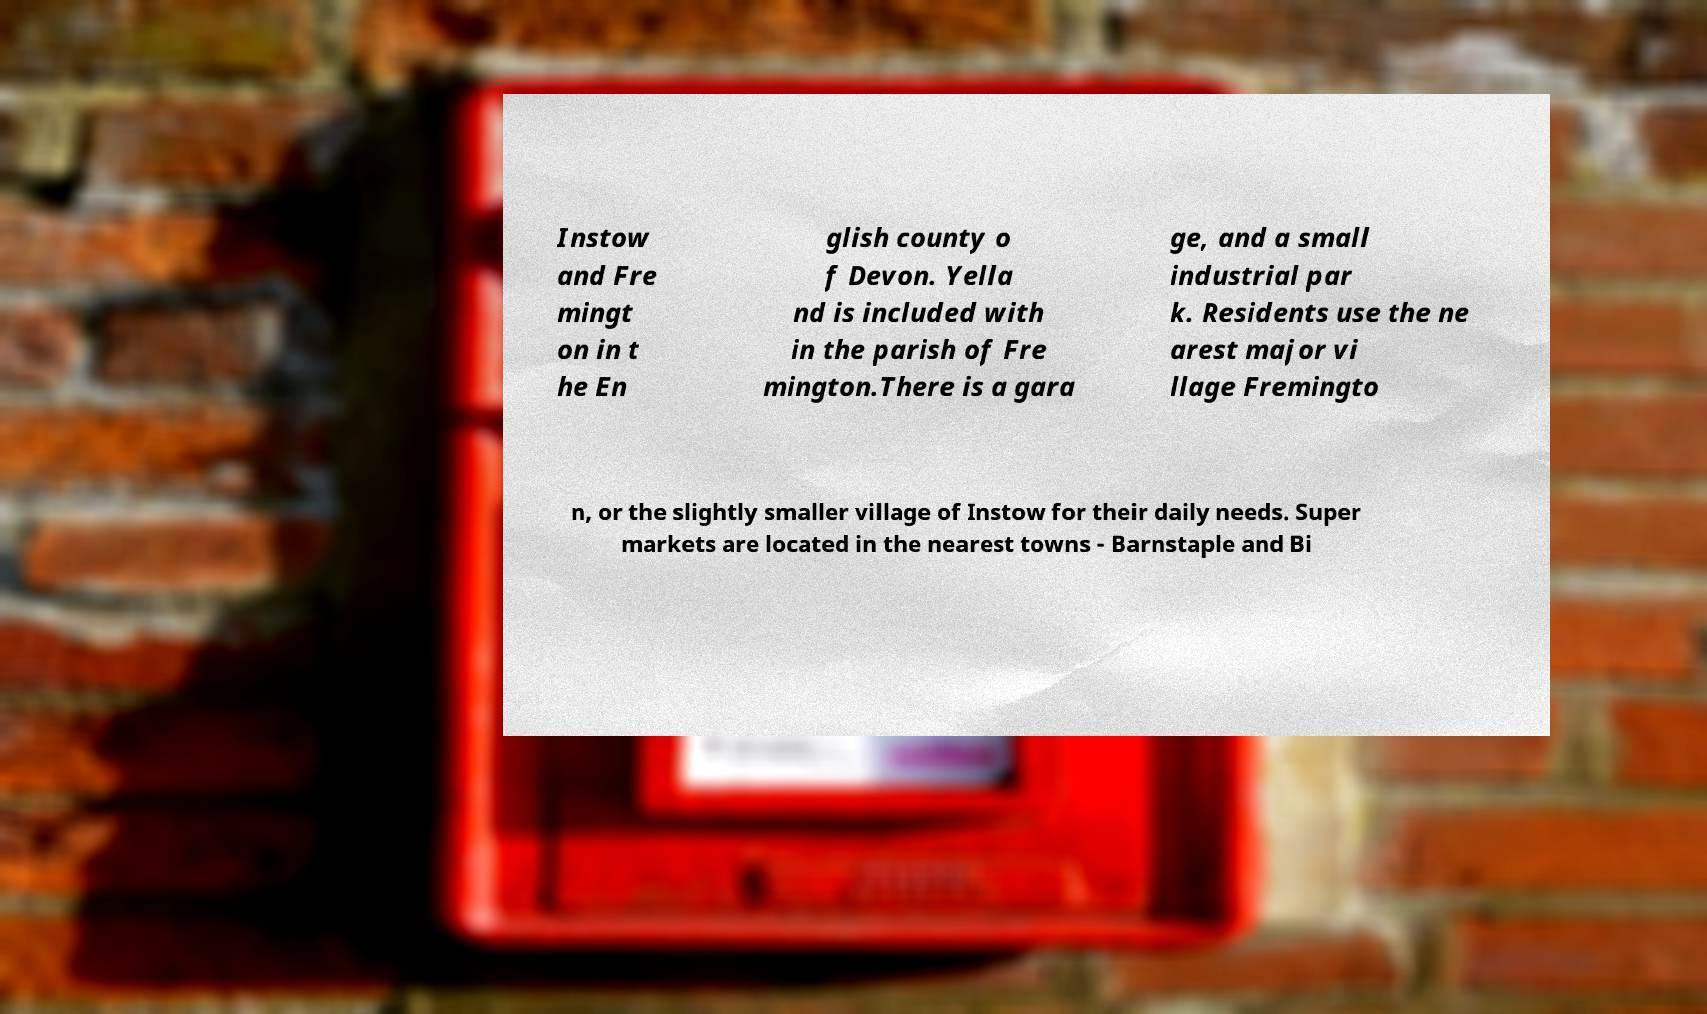Could you assist in decoding the text presented in this image and type it out clearly? Instow and Fre mingt on in t he En glish county o f Devon. Yella nd is included with in the parish of Fre mington.There is a gara ge, and a small industrial par k. Residents use the ne arest major vi llage Fremingto n, or the slightly smaller village of Instow for their daily needs. Super markets are located in the nearest towns - Barnstaple and Bi 